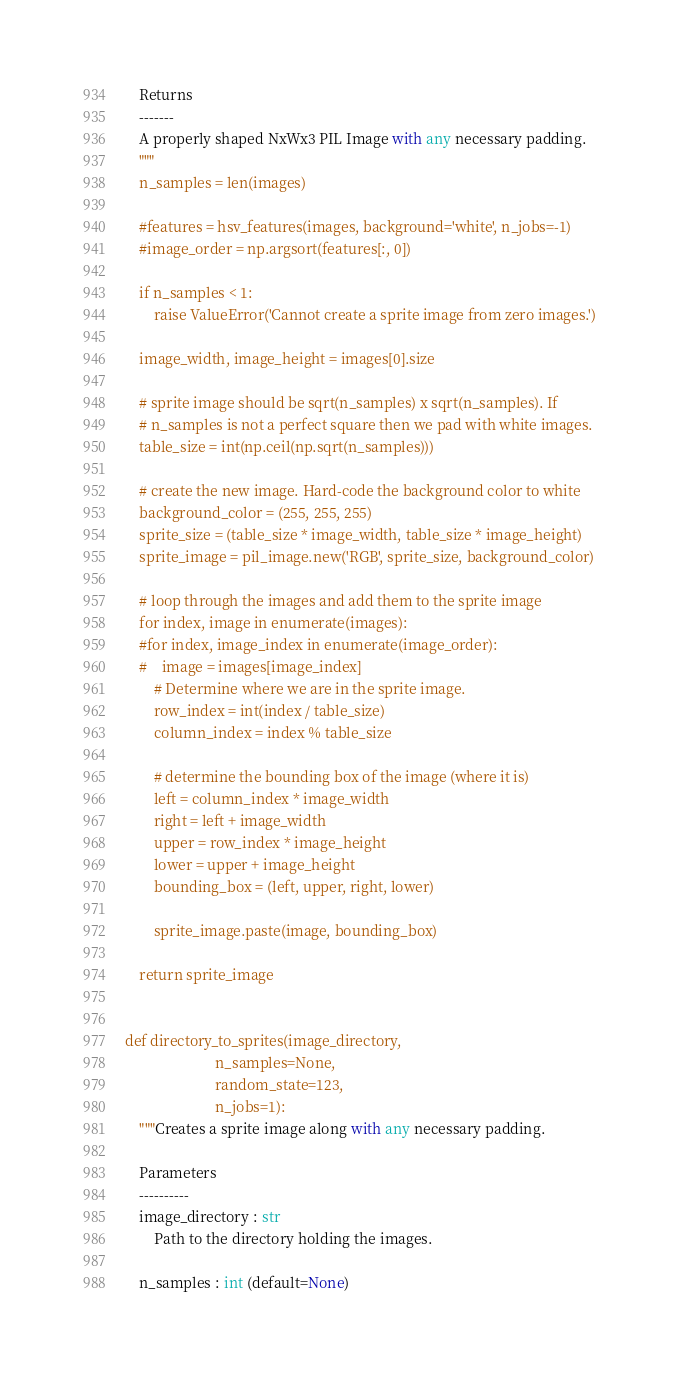Convert code to text. <code><loc_0><loc_0><loc_500><loc_500><_Python_>    Returns
    -------
    A properly shaped NxWx3 PIL Image with any necessary padding.
    """
    n_samples = len(images)

    #features = hsv_features(images, background='white', n_jobs=-1)
    #image_order = np.argsort(features[:, 0])

    if n_samples < 1:
        raise ValueError('Cannot create a sprite image from zero images.')

    image_width, image_height = images[0].size

    # sprite image should be sqrt(n_samples) x sqrt(n_samples). If
    # n_samples is not a perfect square then we pad with white images.
    table_size = int(np.ceil(np.sqrt(n_samples)))

    # create the new image. Hard-code the background color to white
    background_color = (255, 255, 255)
    sprite_size = (table_size * image_width, table_size * image_height)
    sprite_image = pil_image.new('RGB', sprite_size, background_color)

    # loop through the images and add them to the sprite image
    for index, image in enumerate(images):
    #for index, image_index in enumerate(image_order):
    #    image = images[image_index]
        # Determine where we are in the sprite image.
        row_index = int(index / table_size)
        column_index = index % table_size

        # determine the bounding box of the image (where it is)
        left = column_index * image_width
        right = left + image_width
        upper = row_index * image_height
        lower = upper + image_height
        bounding_box = (left, upper, right, lower)

        sprite_image.paste(image, bounding_box)

    return sprite_image


def directory_to_sprites(image_directory,
                         n_samples=None,
                         random_state=123,
                         n_jobs=1):
    """Creates a sprite image along with any necessary padding.

    Parameters
    ----------
    image_directory : str
        Path to the directory holding the images.

    n_samples : int (default=None)</code> 